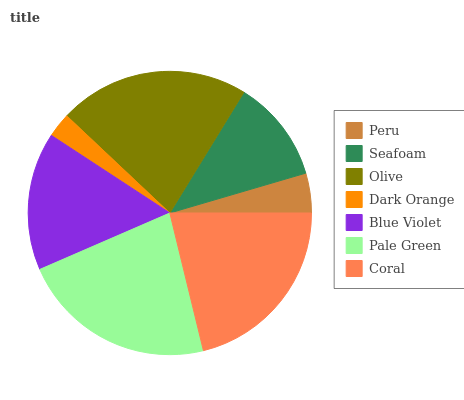Is Dark Orange the minimum?
Answer yes or no. Yes. Is Pale Green the maximum?
Answer yes or no. Yes. Is Seafoam the minimum?
Answer yes or no. No. Is Seafoam the maximum?
Answer yes or no. No. Is Seafoam greater than Peru?
Answer yes or no. Yes. Is Peru less than Seafoam?
Answer yes or no. Yes. Is Peru greater than Seafoam?
Answer yes or no. No. Is Seafoam less than Peru?
Answer yes or no. No. Is Blue Violet the high median?
Answer yes or no. Yes. Is Blue Violet the low median?
Answer yes or no. Yes. Is Seafoam the high median?
Answer yes or no. No. Is Olive the low median?
Answer yes or no. No. 